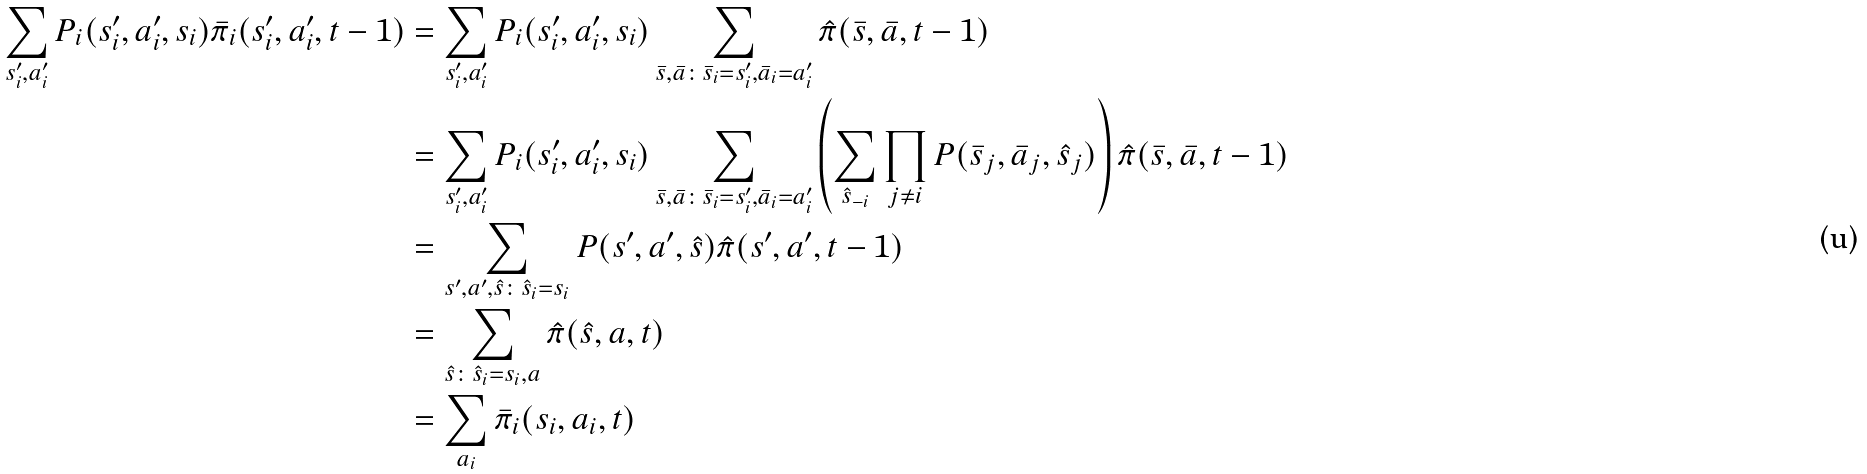<formula> <loc_0><loc_0><loc_500><loc_500>\sum _ { s ^ { \prime } _ { i } , a ^ { \prime } _ { i } } P _ { i } ( s _ { i } ^ { \prime } , a _ { i } ^ { \prime } , s _ { i } ) \bar { \pi } _ { i } ( s _ { i } ^ { \prime } , a _ { i } ^ { \prime } , t - 1 ) & = \sum _ { s ^ { \prime } _ { i } , a ^ { \prime } _ { i } } P _ { i } ( s _ { i } ^ { \prime } , a _ { i } ^ { \prime } , s _ { i } ) \sum _ { \bar { s } , \bar { a } \colon \bar { s } _ { i } = s ^ { \prime } _ { i } , \bar { a } _ { i } = a ^ { \prime } _ { i } } \hat { \pi } ( \bar { s } , \bar { a } , t - 1 ) \\ & = \sum _ { s ^ { \prime } _ { i } , a ^ { \prime } _ { i } } P _ { i } ( s _ { i } ^ { \prime } , a _ { i } ^ { \prime } , s _ { i } ) \sum _ { \bar { s } , \bar { a } \colon \bar { s } _ { i } = s ^ { \prime } _ { i } , \bar { a } _ { i } = a ^ { \prime } _ { i } } \left ( \sum _ { \hat { s } _ { - i } } \prod _ { j \neq i } P ( \bar { s } _ { j } , \bar { a } _ { j } , \hat { s } _ { j } ) \right ) \hat { \pi } ( \bar { s } , \bar { a } , t - 1 ) \\ & = \sum _ { s ^ { \prime } , a ^ { \prime } , \hat { s } \colon \hat { s } _ { i } = s _ { i } } P ( s ^ { \prime } , a ^ { \prime } , \hat { s } ) \hat { \pi } ( s ^ { \prime } , a ^ { \prime } , t - 1 ) \\ & = \sum _ { \hat { s } \colon \hat { s } _ { i } = s _ { i } , a } \hat { \pi } ( \hat { s } , a , t ) \\ & = \sum _ { a _ { i } } \bar { \pi } _ { i } ( s _ { i } , a _ { i } , t )</formula> 